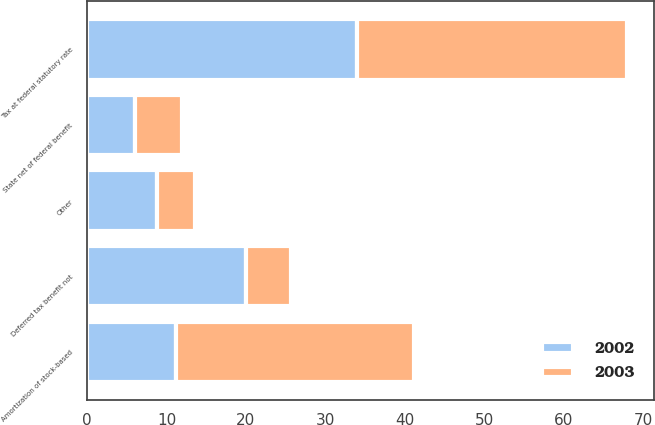Convert chart to OTSL. <chart><loc_0><loc_0><loc_500><loc_500><stacked_bar_chart><ecel><fcel>Tax at federal statutory rate<fcel>State net of federal benefit<fcel>Deferred tax benefit not<fcel>Amortization of stock-based<fcel>Other<nl><fcel>2003<fcel>34<fcel>6<fcel>5.64<fcel>30<fcel>4.78<nl><fcel>2002<fcel>34<fcel>6<fcel>20<fcel>11.15<fcel>8.85<nl></chart> 